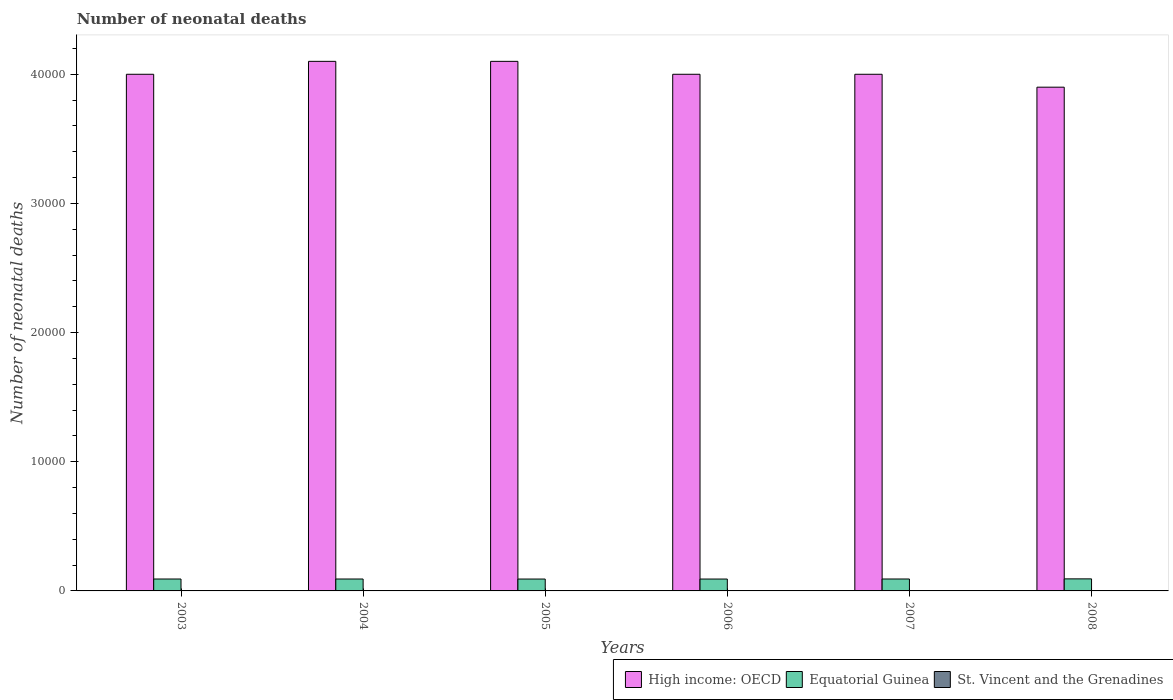How many bars are there on the 4th tick from the left?
Make the answer very short. 3. What is the label of the 3rd group of bars from the left?
Offer a very short reply. 2005. What is the number of neonatal deaths in in St. Vincent and the Grenadines in 2007?
Your answer should be very brief. 26. Across all years, what is the maximum number of neonatal deaths in in St. Vincent and the Grenadines?
Give a very brief answer. 27. Across all years, what is the minimum number of neonatal deaths in in High income: OECD?
Keep it short and to the point. 3.90e+04. What is the total number of neonatal deaths in in Equatorial Guinea in the graph?
Offer a terse response. 5540. What is the difference between the number of neonatal deaths in in Equatorial Guinea in 2006 and that in 2008?
Ensure brevity in your answer.  -13. What is the difference between the number of neonatal deaths in in Equatorial Guinea in 2007 and the number of neonatal deaths in in High income: OECD in 2005?
Offer a terse response. -4.01e+04. What is the average number of neonatal deaths in in St. Vincent and the Grenadines per year?
Offer a terse response. 26.17. In the year 2006, what is the difference between the number of neonatal deaths in in St. Vincent and the Grenadines and number of neonatal deaths in in High income: OECD?
Your response must be concise. -4.00e+04. What is the ratio of the number of neonatal deaths in in High income: OECD in 2003 to that in 2007?
Make the answer very short. 1. Is the number of neonatal deaths in in Equatorial Guinea in 2004 less than that in 2006?
Give a very brief answer. No. What is the difference between the highest and the lowest number of neonatal deaths in in Equatorial Guinea?
Keep it short and to the point. 13. Is the sum of the number of neonatal deaths in in High income: OECD in 2005 and 2007 greater than the maximum number of neonatal deaths in in Equatorial Guinea across all years?
Ensure brevity in your answer.  Yes. What does the 1st bar from the left in 2005 represents?
Offer a terse response. High income: OECD. What does the 2nd bar from the right in 2004 represents?
Provide a succinct answer. Equatorial Guinea. How many bars are there?
Offer a terse response. 18. Are all the bars in the graph horizontal?
Your response must be concise. No. How many years are there in the graph?
Your answer should be compact. 6. What is the difference between two consecutive major ticks on the Y-axis?
Keep it short and to the point. 10000. Does the graph contain grids?
Provide a short and direct response. No. How are the legend labels stacked?
Provide a short and direct response. Horizontal. What is the title of the graph?
Offer a very short reply. Number of neonatal deaths. Does "Moldova" appear as one of the legend labels in the graph?
Keep it short and to the point. No. What is the label or title of the Y-axis?
Ensure brevity in your answer.  Number of neonatal deaths. What is the Number of neonatal deaths of High income: OECD in 2003?
Offer a terse response. 4.00e+04. What is the Number of neonatal deaths of Equatorial Guinea in 2003?
Offer a very short reply. 922. What is the Number of neonatal deaths in High income: OECD in 2004?
Your response must be concise. 4.10e+04. What is the Number of neonatal deaths in Equatorial Guinea in 2004?
Your answer should be very brief. 922. What is the Number of neonatal deaths of St. Vincent and the Grenadines in 2004?
Provide a short and direct response. 26. What is the Number of neonatal deaths in High income: OECD in 2005?
Your response must be concise. 4.10e+04. What is the Number of neonatal deaths in Equatorial Guinea in 2005?
Your answer should be compact. 920. What is the Number of neonatal deaths in St. Vincent and the Grenadines in 2005?
Provide a short and direct response. 26. What is the Number of neonatal deaths of Equatorial Guinea in 2006?
Your response must be concise. 920. What is the Number of neonatal deaths of Equatorial Guinea in 2007?
Give a very brief answer. 923. What is the Number of neonatal deaths in High income: OECD in 2008?
Ensure brevity in your answer.  3.90e+04. What is the Number of neonatal deaths in Equatorial Guinea in 2008?
Provide a short and direct response. 933. Across all years, what is the maximum Number of neonatal deaths in High income: OECD?
Your answer should be very brief. 4.10e+04. Across all years, what is the maximum Number of neonatal deaths of Equatorial Guinea?
Keep it short and to the point. 933. Across all years, what is the maximum Number of neonatal deaths in St. Vincent and the Grenadines?
Give a very brief answer. 27. Across all years, what is the minimum Number of neonatal deaths of High income: OECD?
Offer a very short reply. 3.90e+04. Across all years, what is the minimum Number of neonatal deaths of Equatorial Guinea?
Offer a very short reply. 920. What is the total Number of neonatal deaths of High income: OECD in the graph?
Your answer should be very brief. 2.41e+05. What is the total Number of neonatal deaths of Equatorial Guinea in the graph?
Your response must be concise. 5540. What is the total Number of neonatal deaths in St. Vincent and the Grenadines in the graph?
Offer a terse response. 157. What is the difference between the Number of neonatal deaths of High income: OECD in 2003 and that in 2004?
Your response must be concise. -1000. What is the difference between the Number of neonatal deaths of St. Vincent and the Grenadines in 2003 and that in 2004?
Your response must be concise. 1. What is the difference between the Number of neonatal deaths in High income: OECD in 2003 and that in 2005?
Your response must be concise. -1000. What is the difference between the Number of neonatal deaths of Equatorial Guinea in 2003 and that in 2005?
Make the answer very short. 2. What is the difference between the Number of neonatal deaths in High income: OECD in 2003 and that in 2007?
Offer a terse response. 0. What is the difference between the Number of neonatal deaths in St. Vincent and the Grenadines in 2003 and that in 2007?
Keep it short and to the point. 1. What is the difference between the Number of neonatal deaths of Equatorial Guinea in 2003 and that in 2008?
Your answer should be compact. -11. What is the difference between the Number of neonatal deaths of High income: OECD in 2004 and that in 2005?
Provide a short and direct response. 0. What is the difference between the Number of neonatal deaths in St. Vincent and the Grenadines in 2004 and that in 2007?
Your answer should be very brief. 0. What is the difference between the Number of neonatal deaths in Equatorial Guinea in 2004 and that in 2008?
Make the answer very short. -11. What is the difference between the Number of neonatal deaths in High income: OECD in 2005 and that in 2006?
Ensure brevity in your answer.  1000. What is the difference between the Number of neonatal deaths in Equatorial Guinea in 2005 and that in 2006?
Make the answer very short. 0. What is the difference between the Number of neonatal deaths of High income: OECD in 2005 and that in 2007?
Your response must be concise. 1000. What is the difference between the Number of neonatal deaths in St. Vincent and the Grenadines in 2005 and that in 2007?
Provide a succinct answer. 0. What is the difference between the Number of neonatal deaths in Equatorial Guinea in 2005 and that in 2008?
Make the answer very short. -13. What is the difference between the Number of neonatal deaths in Equatorial Guinea in 2006 and that in 2008?
Your response must be concise. -13. What is the difference between the Number of neonatal deaths in High income: OECD in 2003 and the Number of neonatal deaths in Equatorial Guinea in 2004?
Provide a succinct answer. 3.91e+04. What is the difference between the Number of neonatal deaths in High income: OECD in 2003 and the Number of neonatal deaths in St. Vincent and the Grenadines in 2004?
Provide a succinct answer. 4.00e+04. What is the difference between the Number of neonatal deaths of Equatorial Guinea in 2003 and the Number of neonatal deaths of St. Vincent and the Grenadines in 2004?
Your answer should be very brief. 896. What is the difference between the Number of neonatal deaths of High income: OECD in 2003 and the Number of neonatal deaths of Equatorial Guinea in 2005?
Ensure brevity in your answer.  3.91e+04. What is the difference between the Number of neonatal deaths of High income: OECD in 2003 and the Number of neonatal deaths of St. Vincent and the Grenadines in 2005?
Keep it short and to the point. 4.00e+04. What is the difference between the Number of neonatal deaths of Equatorial Guinea in 2003 and the Number of neonatal deaths of St. Vincent and the Grenadines in 2005?
Offer a very short reply. 896. What is the difference between the Number of neonatal deaths of High income: OECD in 2003 and the Number of neonatal deaths of Equatorial Guinea in 2006?
Give a very brief answer. 3.91e+04. What is the difference between the Number of neonatal deaths in High income: OECD in 2003 and the Number of neonatal deaths in St. Vincent and the Grenadines in 2006?
Ensure brevity in your answer.  4.00e+04. What is the difference between the Number of neonatal deaths of Equatorial Guinea in 2003 and the Number of neonatal deaths of St. Vincent and the Grenadines in 2006?
Give a very brief answer. 896. What is the difference between the Number of neonatal deaths in High income: OECD in 2003 and the Number of neonatal deaths in Equatorial Guinea in 2007?
Offer a terse response. 3.91e+04. What is the difference between the Number of neonatal deaths of High income: OECD in 2003 and the Number of neonatal deaths of St. Vincent and the Grenadines in 2007?
Offer a terse response. 4.00e+04. What is the difference between the Number of neonatal deaths in Equatorial Guinea in 2003 and the Number of neonatal deaths in St. Vincent and the Grenadines in 2007?
Give a very brief answer. 896. What is the difference between the Number of neonatal deaths in High income: OECD in 2003 and the Number of neonatal deaths in Equatorial Guinea in 2008?
Your answer should be very brief. 3.91e+04. What is the difference between the Number of neonatal deaths of High income: OECD in 2003 and the Number of neonatal deaths of St. Vincent and the Grenadines in 2008?
Give a very brief answer. 4.00e+04. What is the difference between the Number of neonatal deaths of Equatorial Guinea in 2003 and the Number of neonatal deaths of St. Vincent and the Grenadines in 2008?
Ensure brevity in your answer.  896. What is the difference between the Number of neonatal deaths of High income: OECD in 2004 and the Number of neonatal deaths of Equatorial Guinea in 2005?
Offer a very short reply. 4.01e+04. What is the difference between the Number of neonatal deaths in High income: OECD in 2004 and the Number of neonatal deaths in St. Vincent and the Grenadines in 2005?
Offer a very short reply. 4.10e+04. What is the difference between the Number of neonatal deaths in Equatorial Guinea in 2004 and the Number of neonatal deaths in St. Vincent and the Grenadines in 2005?
Ensure brevity in your answer.  896. What is the difference between the Number of neonatal deaths in High income: OECD in 2004 and the Number of neonatal deaths in Equatorial Guinea in 2006?
Ensure brevity in your answer.  4.01e+04. What is the difference between the Number of neonatal deaths in High income: OECD in 2004 and the Number of neonatal deaths in St. Vincent and the Grenadines in 2006?
Make the answer very short. 4.10e+04. What is the difference between the Number of neonatal deaths in Equatorial Guinea in 2004 and the Number of neonatal deaths in St. Vincent and the Grenadines in 2006?
Give a very brief answer. 896. What is the difference between the Number of neonatal deaths in High income: OECD in 2004 and the Number of neonatal deaths in Equatorial Guinea in 2007?
Your answer should be compact. 4.01e+04. What is the difference between the Number of neonatal deaths of High income: OECD in 2004 and the Number of neonatal deaths of St. Vincent and the Grenadines in 2007?
Ensure brevity in your answer.  4.10e+04. What is the difference between the Number of neonatal deaths of Equatorial Guinea in 2004 and the Number of neonatal deaths of St. Vincent and the Grenadines in 2007?
Offer a terse response. 896. What is the difference between the Number of neonatal deaths in High income: OECD in 2004 and the Number of neonatal deaths in Equatorial Guinea in 2008?
Provide a short and direct response. 4.01e+04. What is the difference between the Number of neonatal deaths in High income: OECD in 2004 and the Number of neonatal deaths in St. Vincent and the Grenadines in 2008?
Give a very brief answer. 4.10e+04. What is the difference between the Number of neonatal deaths in Equatorial Guinea in 2004 and the Number of neonatal deaths in St. Vincent and the Grenadines in 2008?
Give a very brief answer. 896. What is the difference between the Number of neonatal deaths of High income: OECD in 2005 and the Number of neonatal deaths of Equatorial Guinea in 2006?
Provide a succinct answer. 4.01e+04. What is the difference between the Number of neonatal deaths of High income: OECD in 2005 and the Number of neonatal deaths of St. Vincent and the Grenadines in 2006?
Offer a terse response. 4.10e+04. What is the difference between the Number of neonatal deaths in Equatorial Guinea in 2005 and the Number of neonatal deaths in St. Vincent and the Grenadines in 2006?
Your answer should be compact. 894. What is the difference between the Number of neonatal deaths of High income: OECD in 2005 and the Number of neonatal deaths of Equatorial Guinea in 2007?
Offer a terse response. 4.01e+04. What is the difference between the Number of neonatal deaths of High income: OECD in 2005 and the Number of neonatal deaths of St. Vincent and the Grenadines in 2007?
Give a very brief answer. 4.10e+04. What is the difference between the Number of neonatal deaths of Equatorial Guinea in 2005 and the Number of neonatal deaths of St. Vincent and the Grenadines in 2007?
Ensure brevity in your answer.  894. What is the difference between the Number of neonatal deaths of High income: OECD in 2005 and the Number of neonatal deaths of Equatorial Guinea in 2008?
Give a very brief answer. 4.01e+04. What is the difference between the Number of neonatal deaths in High income: OECD in 2005 and the Number of neonatal deaths in St. Vincent and the Grenadines in 2008?
Give a very brief answer. 4.10e+04. What is the difference between the Number of neonatal deaths of Equatorial Guinea in 2005 and the Number of neonatal deaths of St. Vincent and the Grenadines in 2008?
Give a very brief answer. 894. What is the difference between the Number of neonatal deaths of High income: OECD in 2006 and the Number of neonatal deaths of Equatorial Guinea in 2007?
Offer a terse response. 3.91e+04. What is the difference between the Number of neonatal deaths of High income: OECD in 2006 and the Number of neonatal deaths of St. Vincent and the Grenadines in 2007?
Keep it short and to the point. 4.00e+04. What is the difference between the Number of neonatal deaths in Equatorial Guinea in 2006 and the Number of neonatal deaths in St. Vincent and the Grenadines in 2007?
Your response must be concise. 894. What is the difference between the Number of neonatal deaths in High income: OECD in 2006 and the Number of neonatal deaths in Equatorial Guinea in 2008?
Offer a very short reply. 3.91e+04. What is the difference between the Number of neonatal deaths of High income: OECD in 2006 and the Number of neonatal deaths of St. Vincent and the Grenadines in 2008?
Provide a succinct answer. 4.00e+04. What is the difference between the Number of neonatal deaths of Equatorial Guinea in 2006 and the Number of neonatal deaths of St. Vincent and the Grenadines in 2008?
Give a very brief answer. 894. What is the difference between the Number of neonatal deaths of High income: OECD in 2007 and the Number of neonatal deaths of Equatorial Guinea in 2008?
Make the answer very short. 3.91e+04. What is the difference between the Number of neonatal deaths in High income: OECD in 2007 and the Number of neonatal deaths in St. Vincent and the Grenadines in 2008?
Give a very brief answer. 4.00e+04. What is the difference between the Number of neonatal deaths of Equatorial Guinea in 2007 and the Number of neonatal deaths of St. Vincent and the Grenadines in 2008?
Provide a succinct answer. 897. What is the average Number of neonatal deaths of High income: OECD per year?
Provide a succinct answer. 4.02e+04. What is the average Number of neonatal deaths in Equatorial Guinea per year?
Offer a terse response. 923.33. What is the average Number of neonatal deaths of St. Vincent and the Grenadines per year?
Keep it short and to the point. 26.17. In the year 2003, what is the difference between the Number of neonatal deaths of High income: OECD and Number of neonatal deaths of Equatorial Guinea?
Make the answer very short. 3.91e+04. In the year 2003, what is the difference between the Number of neonatal deaths in High income: OECD and Number of neonatal deaths in St. Vincent and the Grenadines?
Offer a very short reply. 4.00e+04. In the year 2003, what is the difference between the Number of neonatal deaths of Equatorial Guinea and Number of neonatal deaths of St. Vincent and the Grenadines?
Provide a short and direct response. 895. In the year 2004, what is the difference between the Number of neonatal deaths of High income: OECD and Number of neonatal deaths of Equatorial Guinea?
Offer a very short reply. 4.01e+04. In the year 2004, what is the difference between the Number of neonatal deaths of High income: OECD and Number of neonatal deaths of St. Vincent and the Grenadines?
Provide a succinct answer. 4.10e+04. In the year 2004, what is the difference between the Number of neonatal deaths in Equatorial Guinea and Number of neonatal deaths in St. Vincent and the Grenadines?
Provide a succinct answer. 896. In the year 2005, what is the difference between the Number of neonatal deaths in High income: OECD and Number of neonatal deaths in Equatorial Guinea?
Offer a very short reply. 4.01e+04. In the year 2005, what is the difference between the Number of neonatal deaths in High income: OECD and Number of neonatal deaths in St. Vincent and the Grenadines?
Your response must be concise. 4.10e+04. In the year 2005, what is the difference between the Number of neonatal deaths in Equatorial Guinea and Number of neonatal deaths in St. Vincent and the Grenadines?
Make the answer very short. 894. In the year 2006, what is the difference between the Number of neonatal deaths in High income: OECD and Number of neonatal deaths in Equatorial Guinea?
Provide a short and direct response. 3.91e+04. In the year 2006, what is the difference between the Number of neonatal deaths in High income: OECD and Number of neonatal deaths in St. Vincent and the Grenadines?
Your answer should be very brief. 4.00e+04. In the year 2006, what is the difference between the Number of neonatal deaths in Equatorial Guinea and Number of neonatal deaths in St. Vincent and the Grenadines?
Offer a very short reply. 894. In the year 2007, what is the difference between the Number of neonatal deaths of High income: OECD and Number of neonatal deaths of Equatorial Guinea?
Keep it short and to the point. 3.91e+04. In the year 2007, what is the difference between the Number of neonatal deaths in High income: OECD and Number of neonatal deaths in St. Vincent and the Grenadines?
Your answer should be compact. 4.00e+04. In the year 2007, what is the difference between the Number of neonatal deaths of Equatorial Guinea and Number of neonatal deaths of St. Vincent and the Grenadines?
Your answer should be very brief. 897. In the year 2008, what is the difference between the Number of neonatal deaths in High income: OECD and Number of neonatal deaths in Equatorial Guinea?
Your answer should be very brief. 3.81e+04. In the year 2008, what is the difference between the Number of neonatal deaths of High income: OECD and Number of neonatal deaths of St. Vincent and the Grenadines?
Your answer should be very brief. 3.90e+04. In the year 2008, what is the difference between the Number of neonatal deaths of Equatorial Guinea and Number of neonatal deaths of St. Vincent and the Grenadines?
Ensure brevity in your answer.  907. What is the ratio of the Number of neonatal deaths in High income: OECD in 2003 to that in 2004?
Your response must be concise. 0.98. What is the ratio of the Number of neonatal deaths of Equatorial Guinea in 2003 to that in 2004?
Your response must be concise. 1. What is the ratio of the Number of neonatal deaths in High income: OECD in 2003 to that in 2005?
Give a very brief answer. 0.98. What is the ratio of the Number of neonatal deaths in Equatorial Guinea in 2003 to that in 2005?
Offer a very short reply. 1. What is the ratio of the Number of neonatal deaths in Equatorial Guinea in 2003 to that in 2007?
Your response must be concise. 1. What is the ratio of the Number of neonatal deaths in High income: OECD in 2003 to that in 2008?
Your response must be concise. 1.03. What is the ratio of the Number of neonatal deaths in High income: OECD in 2004 to that in 2005?
Offer a very short reply. 1. What is the ratio of the Number of neonatal deaths of Equatorial Guinea in 2004 to that in 2005?
Provide a succinct answer. 1. What is the ratio of the Number of neonatal deaths of High income: OECD in 2004 to that in 2006?
Your answer should be very brief. 1.02. What is the ratio of the Number of neonatal deaths of St. Vincent and the Grenadines in 2004 to that in 2006?
Ensure brevity in your answer.  1. What is the ratio of the Number of neonatal deaths of Equatorial Guinea in 2004 to that in 2007?
Provide a succinct answer. 1. What is the ratio of the Number of neonatal deaths in High income: OECD in 2004 to that in 2008?
Provide a short and direct response. 1.05. What is the ratio of the Number of neonatal deaths in St. Vincent and the Grenadines in 2004 to that in 2008?
Provide a succinct answer. 1. What is the ratio of the Number of neonatal deaths of Equatorial Guinea in 2005 to that in 2006?
Offer a terse response. 1. What is the ratio of the Number of neonatal deaths in Equatorial Guinea in 2005 to that in 2007?
Offer a terse response. 1. What is the ratio of the Number of neonatal deaths in High income: OECD in 2005 to that in 2008?
Your response must be concise. 1.05. What is the ratio of the Number of neonatal deaths of Equatorial Guinea in 2005 to that in 2008?
Keep it short and to the point. 0.99. What is the ratio of the Number of neonatal deaths of St. Vincent and the Grenadines in 2005 to that in 2008?
Ensure brevity in your answer.  1. What is the ratio of the Number of neonatal deaths of High income: OECD in 2006 to that in 2007?
Ensure brevity in your answer.  1. What is the ratio of the Number of neonatal deaths of Equatorial Guinea in 2006 to that in 2007?
Provide a short and direct response. 1. What is the ratio of the Number of neonatal deaths in High income: OECD in 2006 to that in 2008?
Offer a very short reply. 1.03. What is the ratio of the Number of neonatal deaths of Equatorial Guinea in 2006 to that in 2008?
Your answer should be very brief. 0.99. What is the ratio of the Number of neonatal deaths of High income: OECD in 2007 to that in 2008?
Provide a short and direct response. 1.03. What is the ratio of the Number of neonatal deaths of Equatorial Guinea in 2007 to that in 2008?
Your answer should be very brief. 0.99. What is the ratio of the Number of neonatal deaths of St. Vincent and the Grenadines in 2007 to that in 2008?
Ensure brevity in your answer.  1. What is the difference between the highest and the second highest Number of neonatal deaths of High income: OECD?
Provide a short and direct response. 0. What is the difference between the highest and the second highest Number of neonatal deaths in Equatorial Guinea?
Your answer should be compact. 10. What is the difference between the highest and the lowest Number of neonatal deaths of High income: OECD?
Your answer should be very brief. 2000. What is the difference between the highest and the lowest Number of neonatal deaths in Equatorial Guinea?
Your answer should be compact. 13. What is the difference between the highest and the lowest Number of neonatal deaths of St. Vincent and the Grenadines?
Your answer should be very brief. 1. 